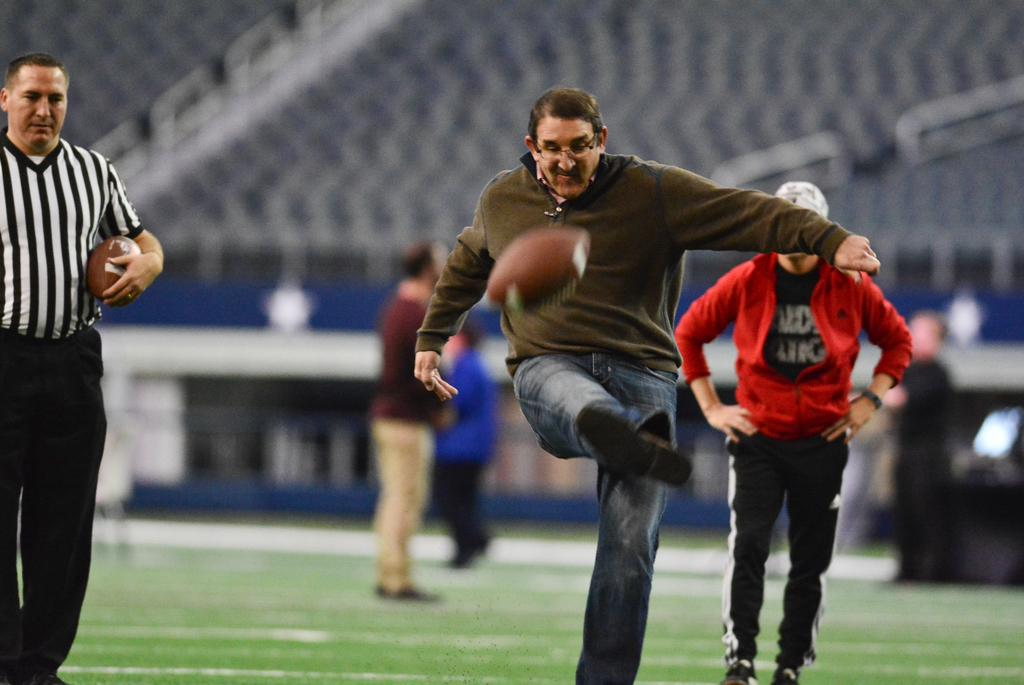What sport are the people playing in the image? The people are playing rugby in the image. What action is the man performing with the rugby ball? The man is hitting the rugby ball with his leg. Can you describe the background of the image? The background of the image is blurry. What type of sign can be seen in the image? There is no sign present in the image; it features people playing rugby with a blurry background. 